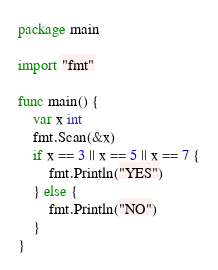Convert code to text. <code><loc_0><loc_0><loc_500><loc_500><_Go_>package main

import "fmt"

func main() {
	var x int
	fmt.Scan(&x)
	if x == 3 || x == 5 || x == 7 {
		fmt.Println("YES")
	} else {
		fmt.Println("NO")
	}
}
</code> 